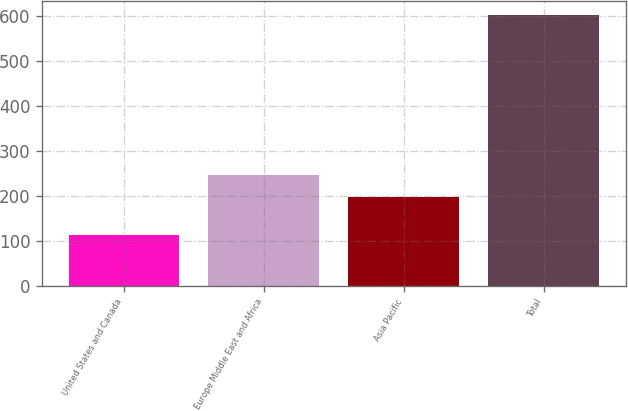Convert chart. <chart><loc_0><loc_0><loc_500><loc_500><bar_chart><fcel>United States and Canada<fcel>Europe Middle East and Africa<fcel>Asia Pacific<fcel>Total<nl><fcel>114<fcel>246.8<fcel>198<fcel>602<nl></chart> 